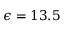Convert formula to latex. <formula><loc_0><loc_0><loc_500><loc_500>\epsilon = 1 3 . 5</formula> 